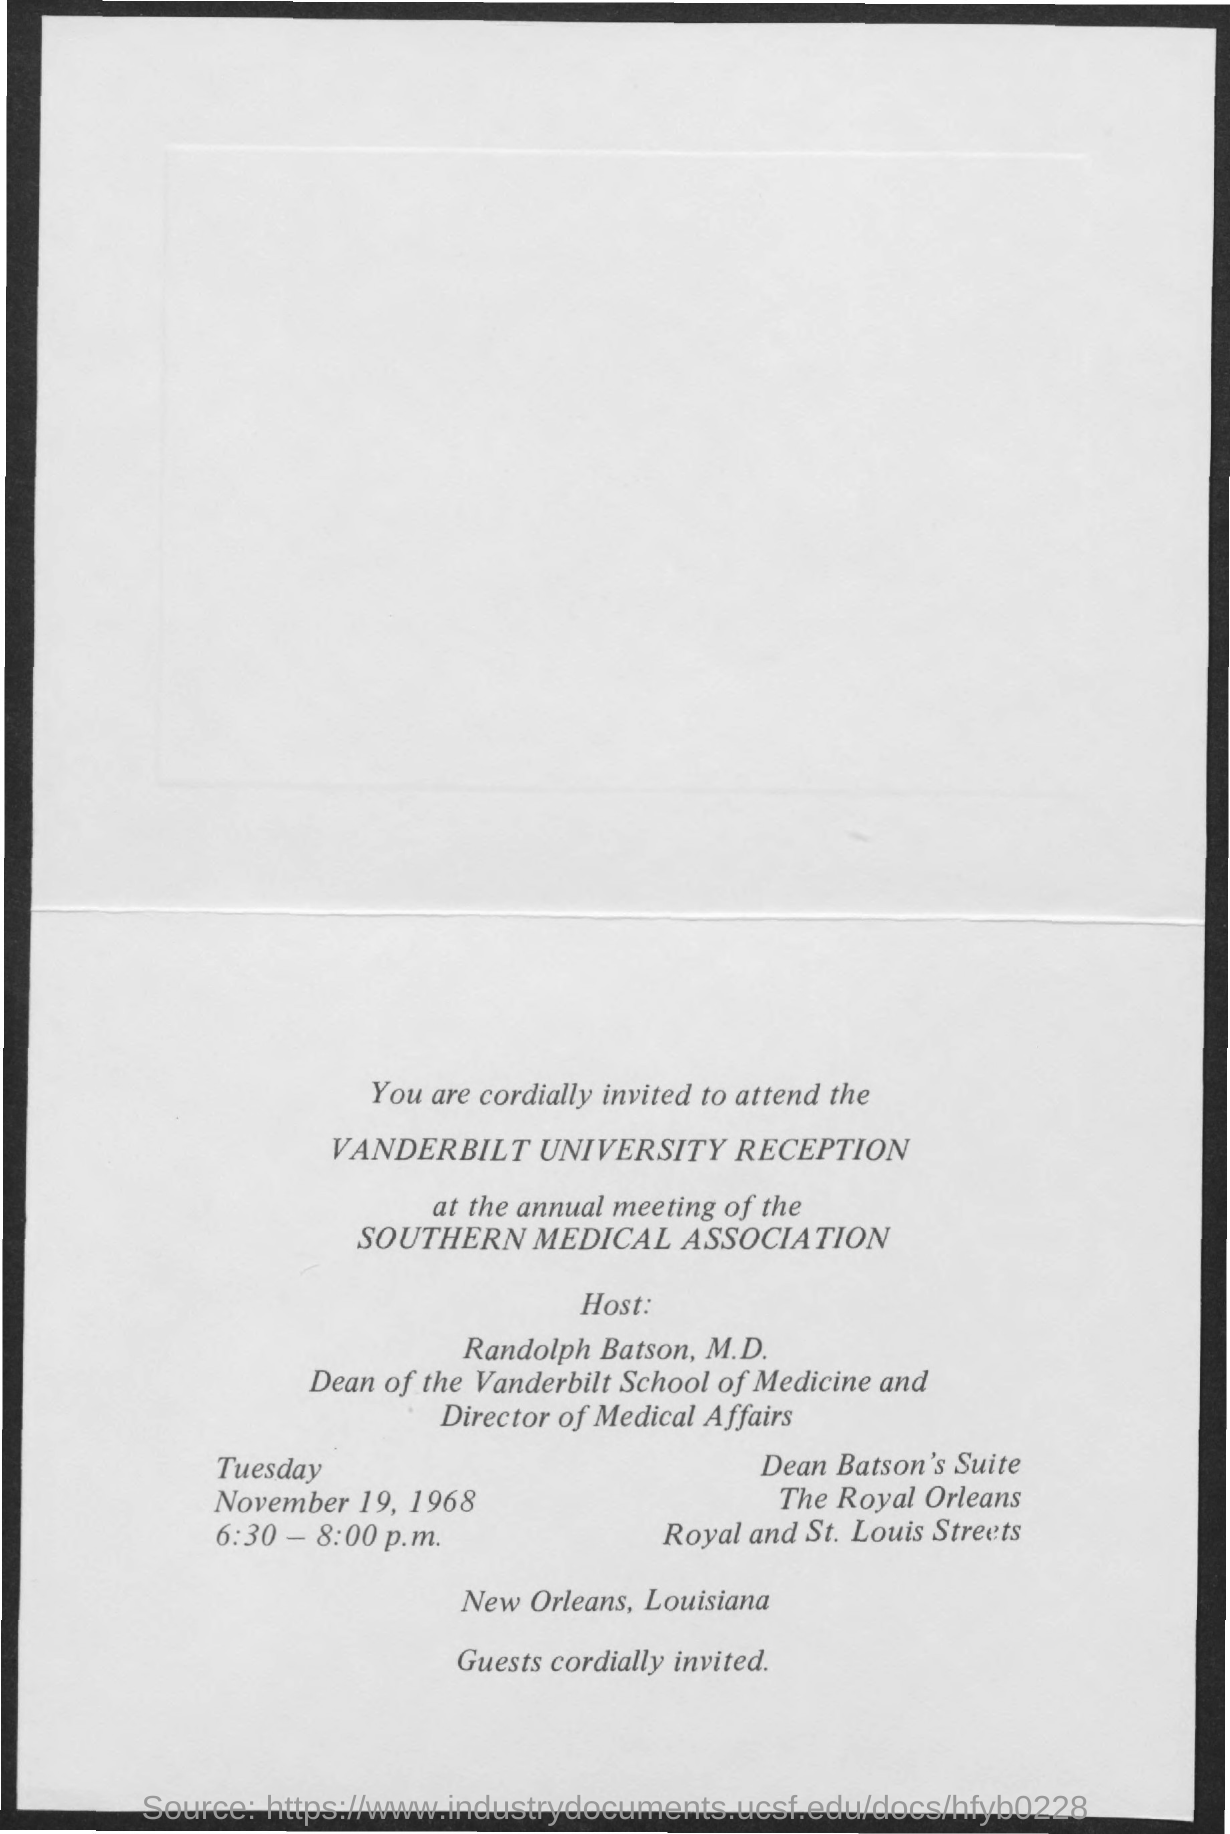Draw attention to some important aspects in this diagram. Randolph Batson, M.D., is the Dean of the Vanderbilt School of Medicine and the Director of Medical Affairs. Randolph Batson, M.D., is the host at the Vanderbilt University Reception. The Vanderbilt University reception at the Southern Medical Association's annual meeting will be held from 6:30 pm to 8:00 pm. 